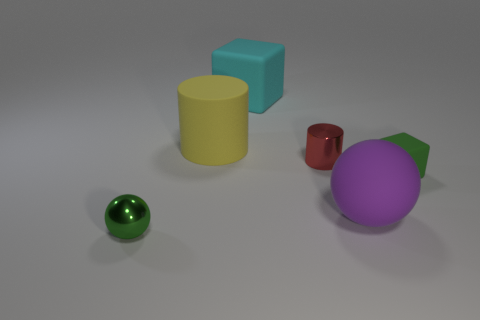Are there any other things that are the same size as the purple object?
Your answer should be compact. Yes. What is the material of the cube that is in front of the metal thing that is on the right side of the green metallic ball?
Keep it short and to the point. Rubber. There is a matte object that is behind the large purple matte ball and on the right side of the small red metal thing; what shape is it?
Provide a short and direct response. Cube. What is the size of the green thing that is the same shape as the large purple thing?
Give a very brief answer. Small. Is the number of tiny cylinders that are left of the small green ball less than the number of cyan matte things?
Your answer should be compact. Yes. There is a metallic object to the right of the big matte block; what size is it?
Your answer should be very brief. Small. There is a metallic thing that is the same shape as the big purple matte thing; what color is it?
Your response must be concise. Green. How many metal balls have the same color as the tiny cube?
Give a very brief answer. 1. Are there any other things that have the same shape as the small green matte thing?
Ensure brevity in your answer.  Yes. Are there any green blocks that are left of the green thing behind the green thing to the left of the yellow thing?
Ensure brevity in your answer.  No. 